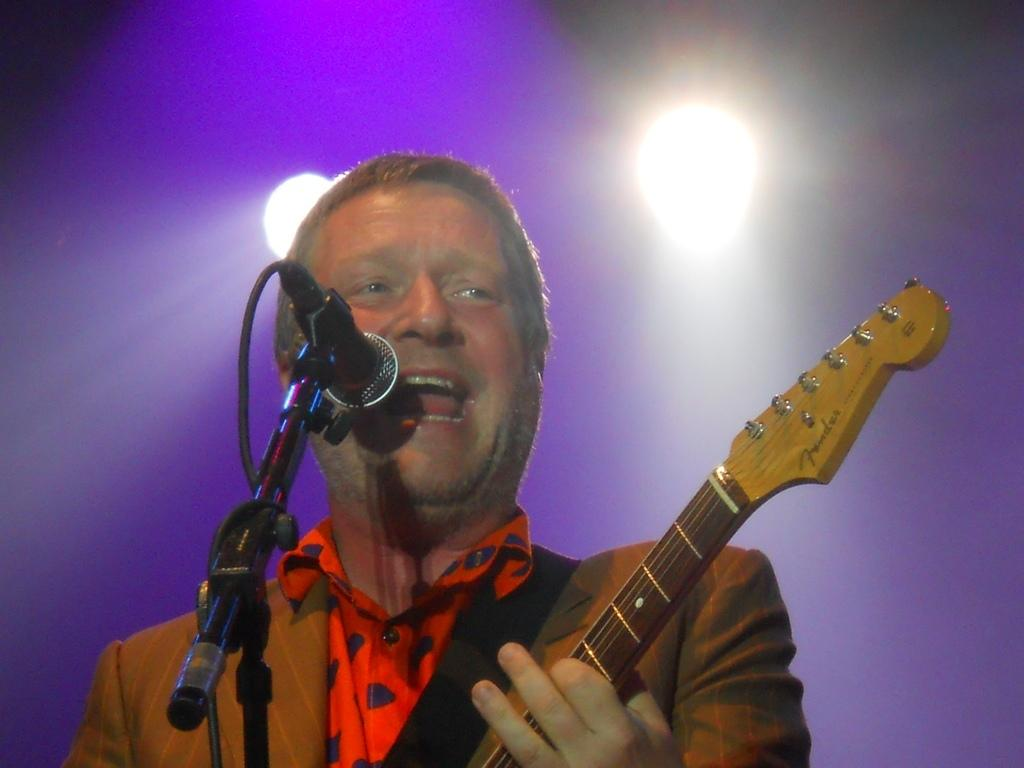What is the man in the image doing? The man is playing a guitar and singing. What object is in front of the man? There is a mic in front of the man. What can be seen above the man in the image? There are focusing lights on top in the image. Can you see any wishes being granted in the image? There is no mention or indication of wishes being granted in the image. What type of mitten is the man wearing on his left hand while playing the guitar? The man is not wearing any mittens in the image; he is playing the guitar with his bare hands. 